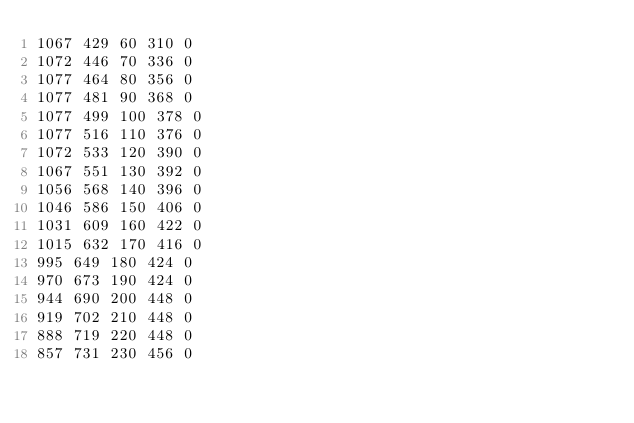<code> <loc_0><loc_0><loc_500><loc_500><_SML_>1067 429 60 310 0
1072 446 70 336 0
1077 464 80 356 0
1077 481 90 368 0
1077 499 100 378 0
1077 516 110 376 0
1072 533 120 390 0
1067 551 130 392 0
1056 568 140 396 0
1046 586 150 406 0
1031 609 160 422 0
1015 632 170 416 0
995 649 180 424 0
970 673 190 424 0
944 690 200 448 0
919 702 210 448 0
888 719 220 448 0
857 731 230 456 0</code> 